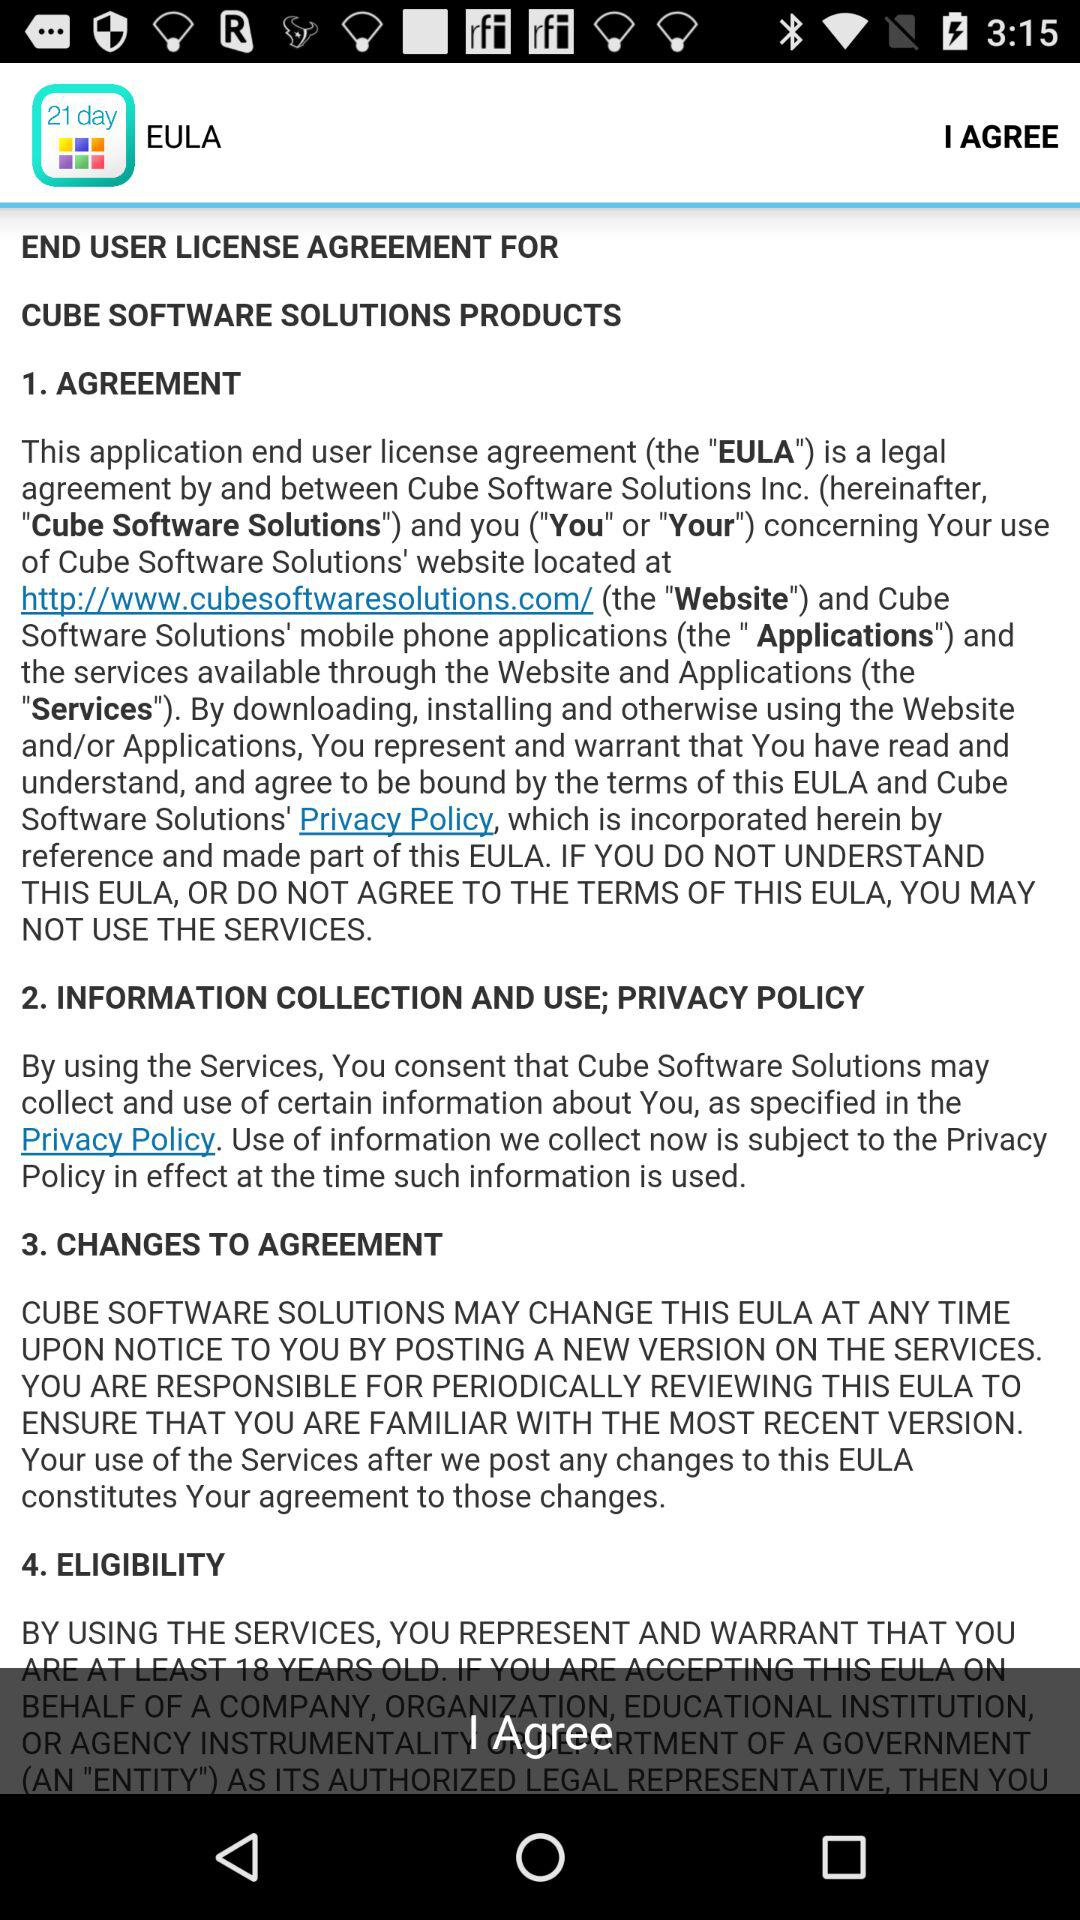How many sections are in this EULA?
Answer the question using a single word or phrase. 4 